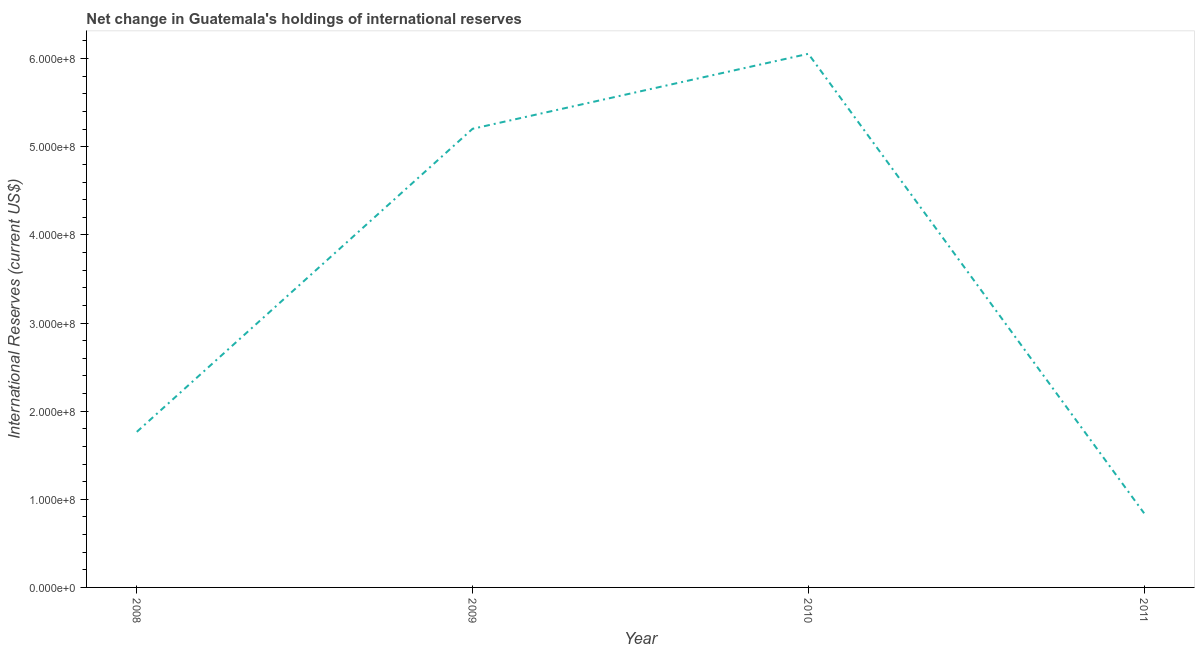What is the reserves and related items in 2010?
Offer a terse response. 6.05e+08. Across all years, what is the maximum reserves and related items?
Your answer should be very brief. 6.05e+08. Across all years, what is the minimum reserves and related items?
Give a very brief answer. 8.41e+07. In which year was the reserves and related items maximum?
Your response must be concise. 2010. What is the sum of the reserves and related items?
Ensure brevity in your answer.  1.39e+09. What is the difference between the reserves and related items in 2009 and 2011?
Offer a very short reply. 4.36e+08. What is the average reserves and related items per year?
Your response must be concise. 3.47e+08. What is the median reserves and related items?
Provide a short and direct response. 3.48e+08. What is the ratio of the reserves and related items in 2009 to that in 2010?
Provide a short and direct response. 0.86. What is the difference between the highest and the second highest reserves and related items?
Offer a very short reply. 8.51e+07. What is the difference between the highest and the lowest reserves and related items?
Provide a succinct answer. 5.21e+08. Does the reserves and related items monotonically increase over the years?
Keep it short and to the point. No. What is the difference between two consecutive major ticks on the Y-axis?
Give a very brief answer. 1.00e+08. Are the values on the major ticks of Y-axis written in scientific E-notation?
Provide a succinct answer. Yes. Does the graph contain any zero values?
Keep it short and to the point. No. What is the title of the graph?
Provide a succinct answer. Net change in Guatemala's holdings of international reserves. What is the label or title of the Y-axis?
Give a very brief answer. International Reserves (current US$). What is the International Reserves (current US$) of 2008?
Keep it short and to the point. 1.77e+08. What is the International Reserves (current US$) in 2009?
Your response must be concise. 5.20e+08. What is the International Reserves (current US$) in 2010?
Your response must be concise. 6.05e+08. What is the International Reserves (current US$) of 2011?
Give a very brief answer. 8.41e+07. What is the difference between the International Reserves (current US$) in 2008 and 2009?
Your answer should be very brief. -3.44e+08. What is the difference between the International Reserves (current US$) in 2008 and 2010?
Offer a very short reply. -4.29e+08. What is the difference between the International Reserves (current US$) in 2008 and 2011?
Offer a very short reply. 9.24e+07. What is the difference between the International Reserves (current US$) in 2009 and 2010?
Ensure brevity in your answer.  -8.51e+07. What is the difference between the International Reserves (current US$) in 2009 and 2011?
Your answer should be compact. 4.36e+08. What is the difference between the International Reserves (current US$) in 2010 and 2011?
Provide a short and direct response. 5.21e+08. What is the ratio of the International Reserves (current US$) in 2008 to that in 2009?
Offer a very short reply. 0.34. What is the ratio of the International Reserves (current US$) in 2008 to that in 2010?
Give a very brief answer. 0.29. What is the ratio of the International Reserves (current US$) in 2008 to that in 2011?
Provide a short and direct response. 2.1. What is the ratio of the International Reserves (current US$) in 2009 to that in 2010?
Your answer should be compact. 0.86. What is the ratio of the International Reserves (current US$) in 2009 to that in 2011?
Provide a short and direct response. 6.18. What is the ratio of the International Reserves (current US$) in 2010 to that in 2011?
Give a very brief answer. 7.2. 